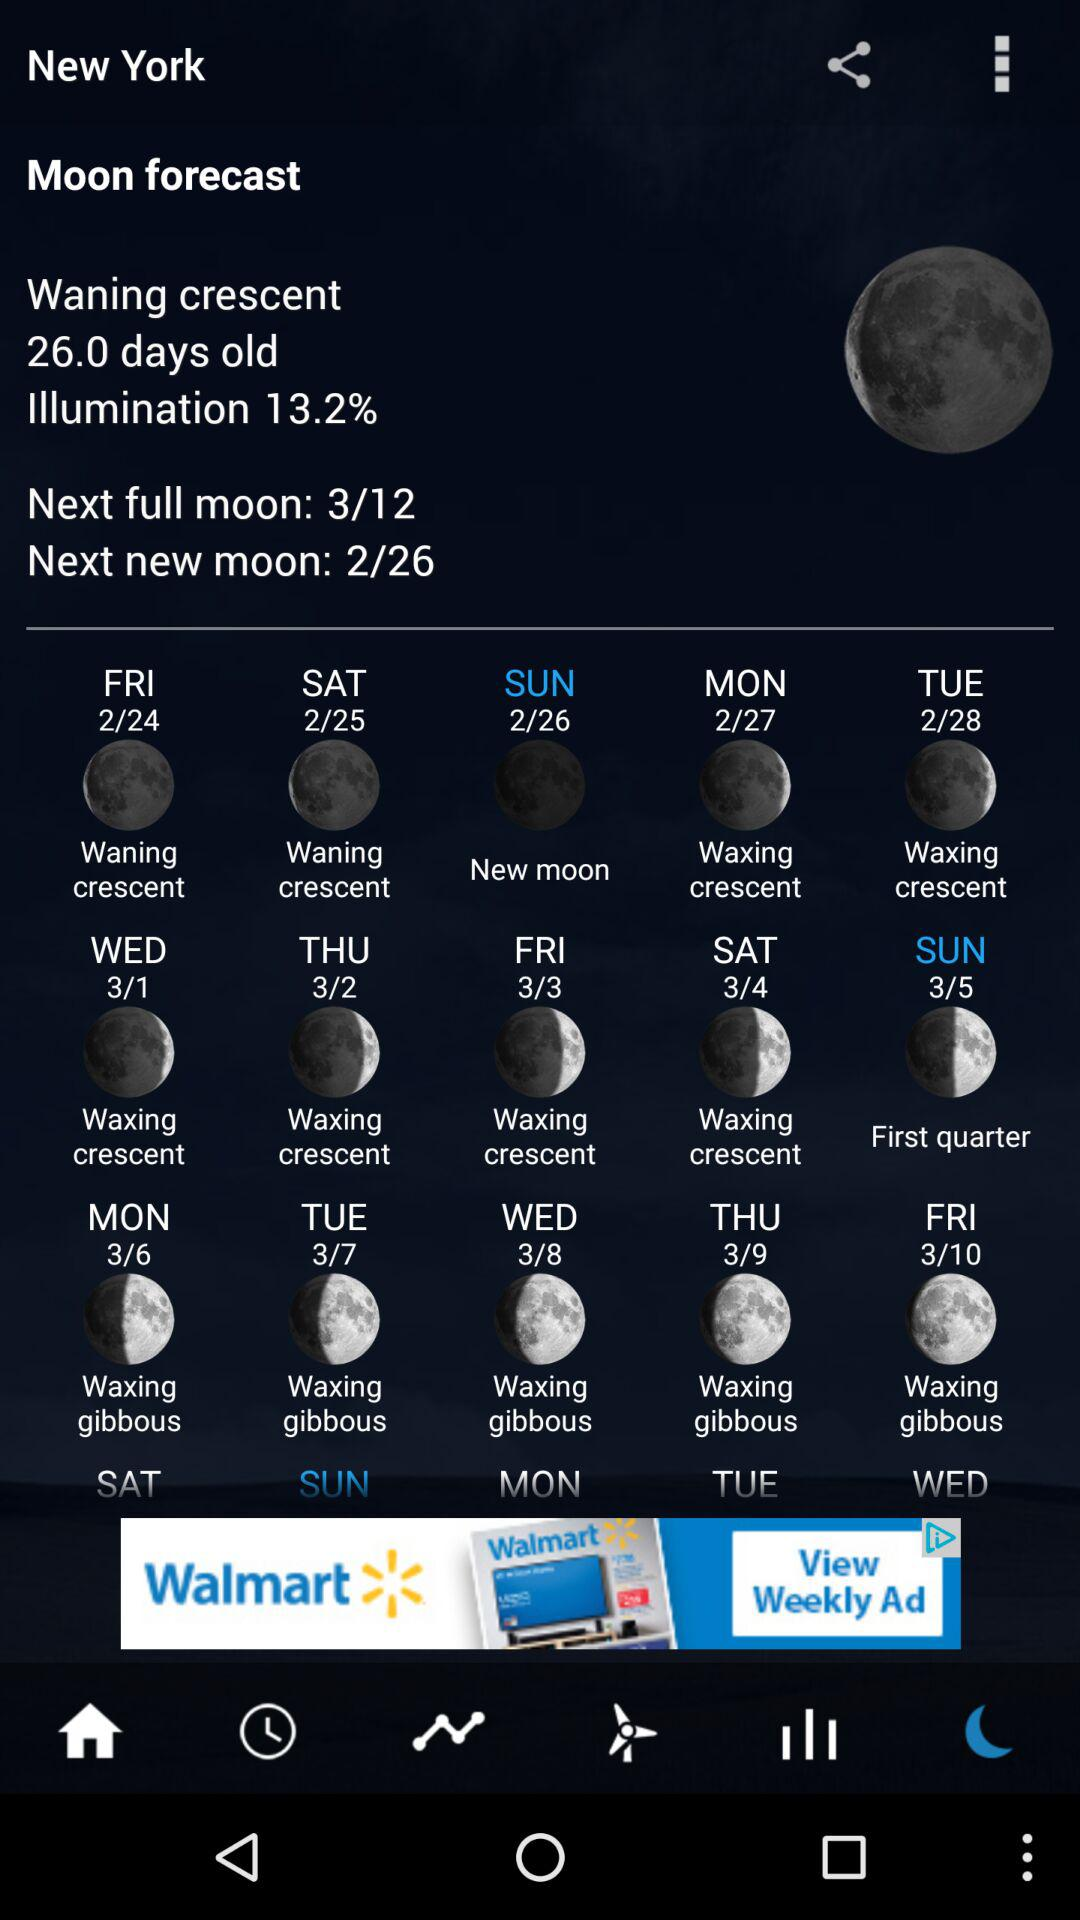What is the current city name? The current city name is New York. 